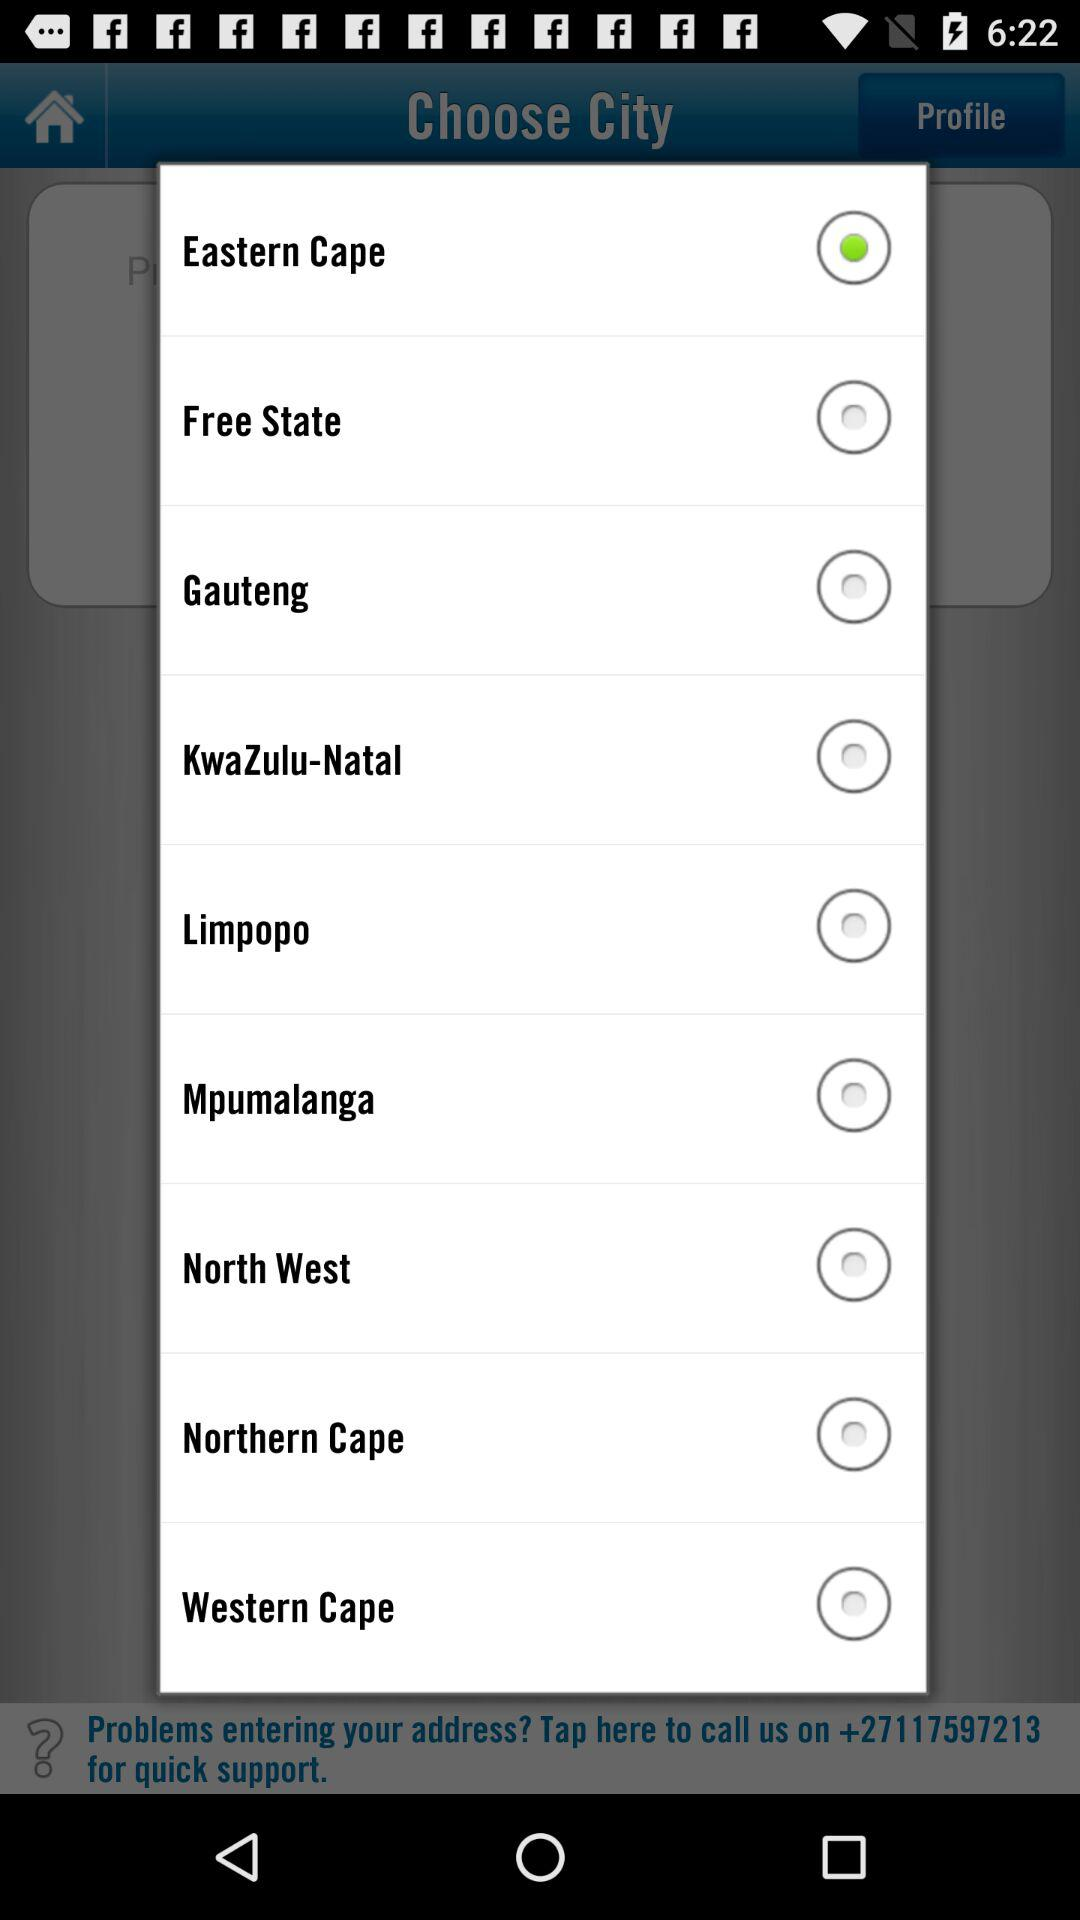Which is the selected city? The selected city is Eastern Cape. 